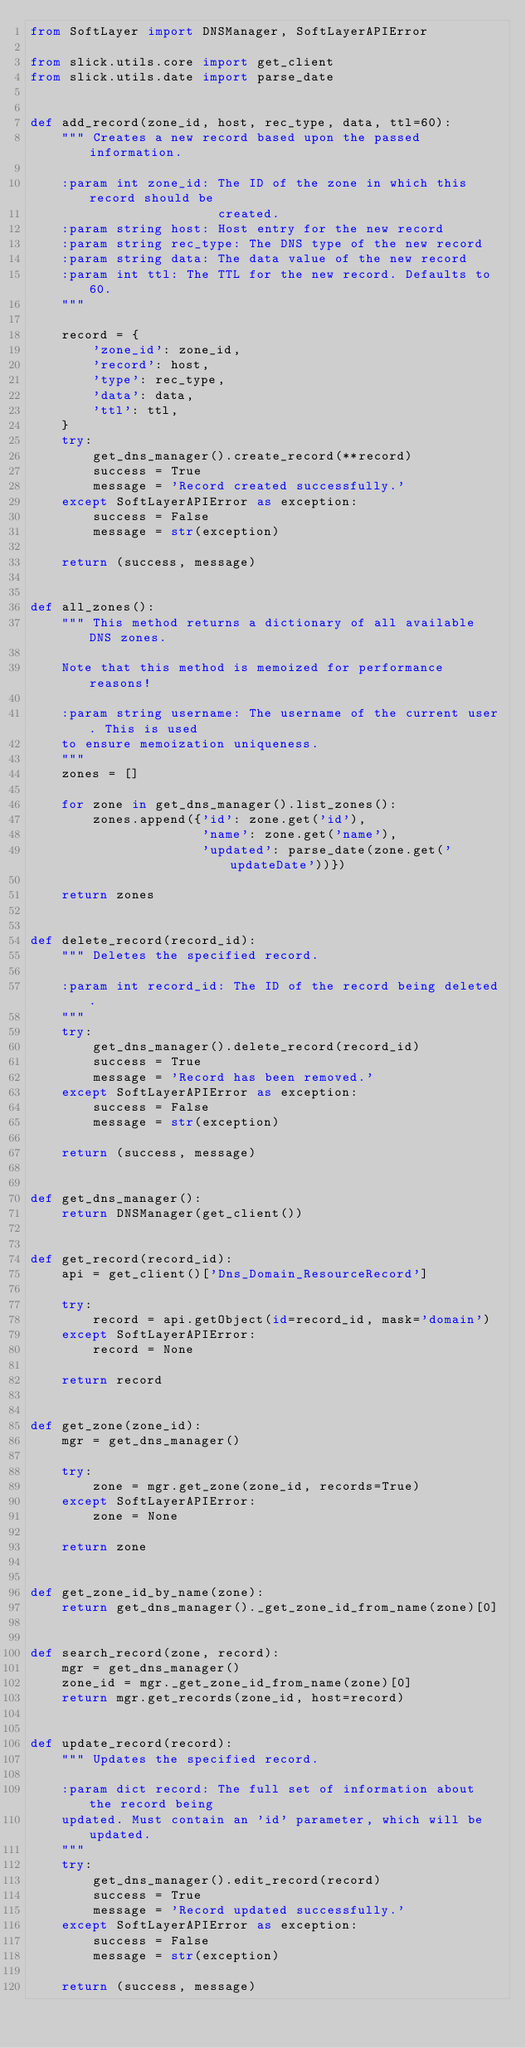<code> <loc_0><loc_0><loc_500><loc_500><_Python_>from SoftLayer import DNSManager, SoftLayerAPIError

from slick.utils.core import get_client
from slick.utils.date import parse_date


def add_record(zone_id, host, rec_type, data, ttl=60):
    """ Creates a new record based upon the passed information.

    :param int zone_id: The ID of the zone in which this record should be
                        created.
    :param string host: Host entry for the new record
    :param string rec_type: The DNS type of the new record
    :param string data: The data value of the new record
    :param int ttl: The TTL for the new record. Defaults to 60.
    """

    record = {
        'zone_id': zone_id,
        'record': host,
        'type': rec_type,
        'data': data,
        'ttl': ttl,
    }
    try:
        get_dns_manager().create_record(**record)
        success = True
        message = 'Record created successfully.'
    except SoftLayerAPIError as exception:
        success = False
        message = str(exception)

    return (success, message)


def all_zones():
    """ This method returns a dictionary of all available DNS zones.

    Note that this method is memoized for performance reasons!

    :param string username: The username of the current user. This is used
    to ensure memoization uniqueness.
    """
    zones = []

    for zone in get_dns_manager().list_zones():
        zones.append({'id': zone.get('id'),
                      'name': zone.get('name'),
                      'updated': parse_date(zone.get('updateDate'))})

    return zones


def delete_record(record_id):
    """ Deletes the specified record.

    :param int record_id: The ID of the record being deleted.
    """
    try:
        get_dns_manager().delete_record(record_id)
        success = True
        message = 'Record has been removed.'
    except SoftLayerAPIError as exception:
        success = False
        message = str(exception)

    return (success, message)


def get_dns_manager():
    return DNSManager(get_client())


def get_record(record_id):
    api = get_client()['Dns_Domain_ResourceRecord']

    try:
        record = api.getObject(id=record_id, mask='domain')
    except SoftLayerAPIError:
        record = None

    return record


def get_zone(zone_id):
    mgr = get_dns_manager()

    try:
        zone = mgr.get_zone(zone_id, records=True)
    except SoftLayerAPIError:
        zone = None

    return zone


def get_zone_id_by_name(zone):
    return get_dns_manager()._get_zone_id_from_name(zone)[0]


def search_record(zone, record):
    mgr = get_dns_manager()
    zone_id = mgr._get_zone_id_from_name(zone)[0]
    return mgr.get_records(zone_id, host=record)


def update_record(record):
    """ Updates the specified record.

    :param dict record: The full set of information about the record being
    updated. Must contain an 'id' parameter, which will be updated.
    """
    try:
        get_dns_manager().edit_record(record)
        success = True
        message = 'Record updated successfully.'
    except SoftLayerAPIError as exception:
        success = False
        message = str(exception)

    return (success, message)
</code> 